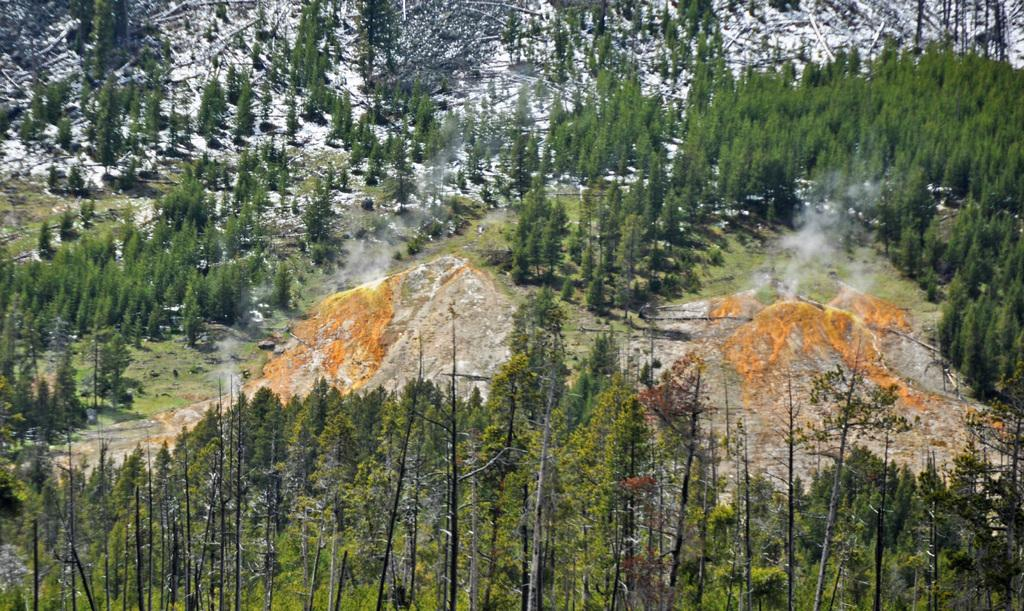What type of vegetation can be seen in the image? There are trees and plants in the image. What is visible beneath the vegetation? The ground is visible in the image. What is the weather like in the image? There is snow on a hill in the image, indicating a cold or snowy environment. What type of boat is being used for treatment in the image? There is no boat or treatment present in the image; it features trees, plants, and snow on a hill. 